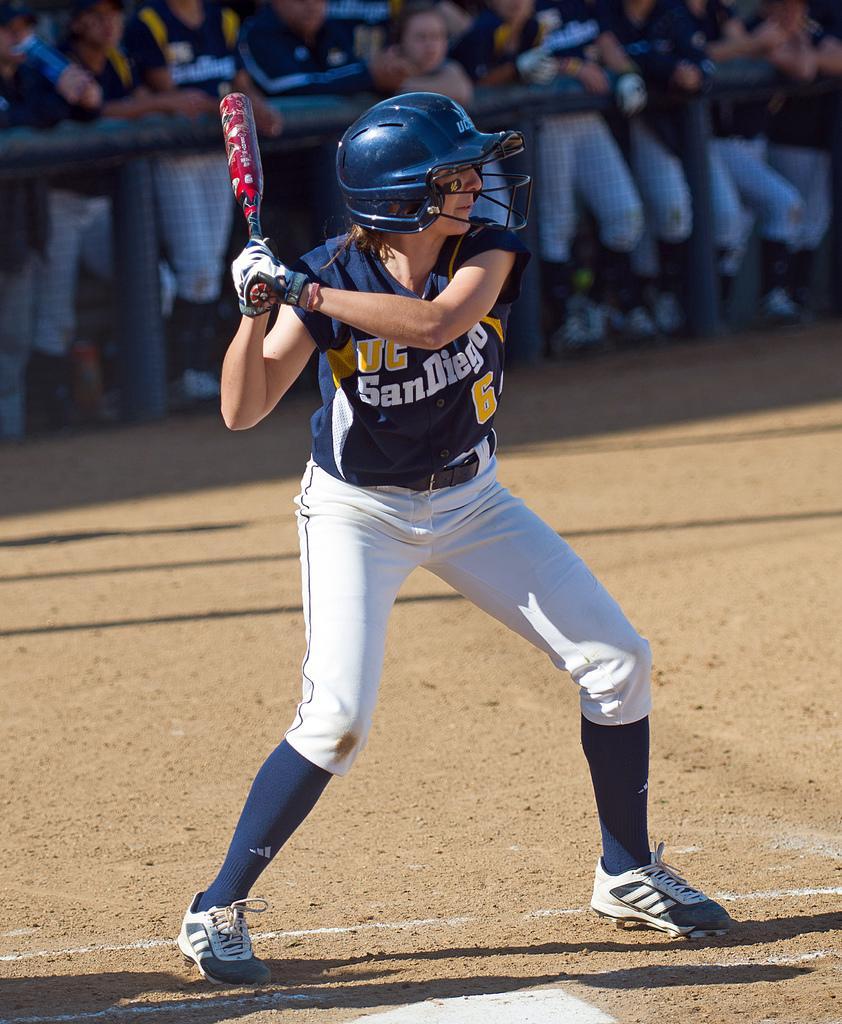In one or two sentences, can you explain what this image depicts? In this image I can see a person is holding a bat in hands. The person is wearing a helmet. In the background I can see group of people standing behind the fence. 